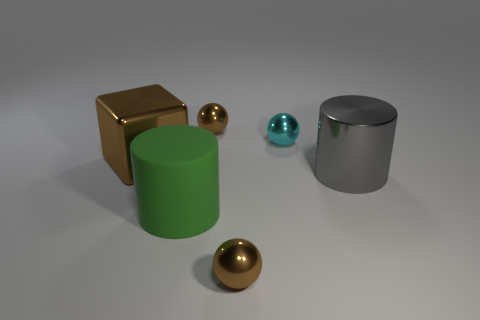What size is the ball that is left of the tiny brown ball in front of the large cylinder that is right of the big green object?
Give a very brief answer. Small. There is another metal thing that is the same shape as the large green thing; what is its size?
Your answer should be compact. Large. What number of small objects are either brown spheres or brown blocks?
Your answer should be very brief. 2. Is the material of the thing that is in front of the green object the same as the big object that is on the right side of the large rubber object?
Provide a succinct answer. Yes. There is a tiny brown thing behind the large brown cube; what is its material?
Provide a succinct answer. Metal. What number of shiny things are either small blue balls or big green cylinders?
Offer a terse response. 0. What is the color of the tiny shiny thing that is to the left of the tiny thing that is in front of the gray metallic cylinder?
Your response must be concise. Brown. Does the gray cylinder have the same material as the small brown ball in front of the large green matte cylinder?
Ensure brevity in your answer.  Yes. What color is the tiny thing that is in front of the brown shiny object that is left of the shiny object behind the small cyan metal sphere?
Offer a terse response. Brown. Is there anything else that has the same shape as the big gray shiny thing?
Ensure brevity in your answer.  Yes. 